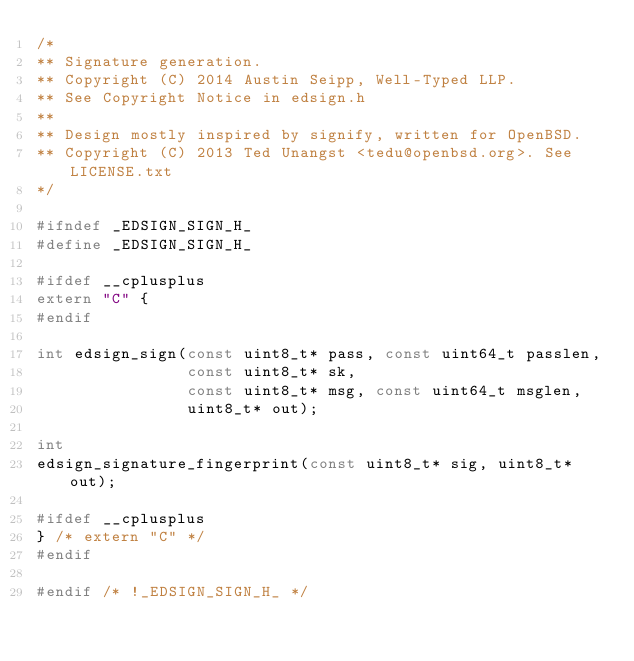<code> <loc_0><loc_0><loc_500><loc_500><_C_>/*
** Signature generation.
** Copyright (C) 2014 Austin Seipp, Well-Typed LLP.
** See Copyright Notice in edsign.h
**
** Design mostly inspired by signify, written for OpenBSD.
** Copyright (C) 2013 Ted Unangst <tedu@openbsd.org>. See LICENSE.txt
*/

#ifndef _EDSIGN_SIGN_H_
#define _EDSIGN_SIGN_H_

#ifdef __cplusplus
extern "C" {
#endif

int edsign_sign(const uint8_t* pass, const uint64_t passlen,
                const uint8_t* sk,
                const uint8_t* msg, const uint64_t msglen,
                uint8_t* out);

int
edsign_signature_fingerprint(const uint8_t* sig, uint8_t* out);

#ifdef __cplusplus
} /* extern "C" */
#endif

#endif /* !_EDSIGN_SIGN_H_ */
</code> 